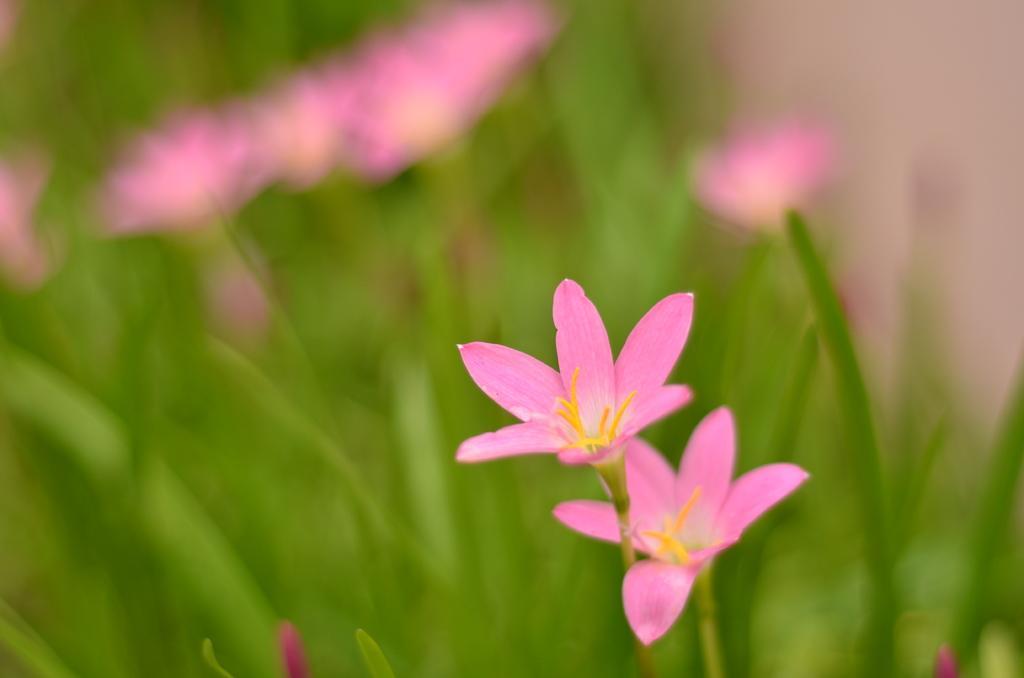How would you summarize this image in a sentence or two? In this picture we observe beautiful pink flowers to the plants. 